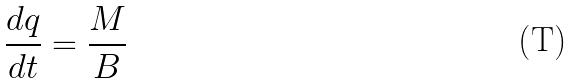Convert formula to latex. <formula><loc_0><loc_0><loc_500><loc_500>\frac { d q } { d t } = \frac { M } { B }</formula> 